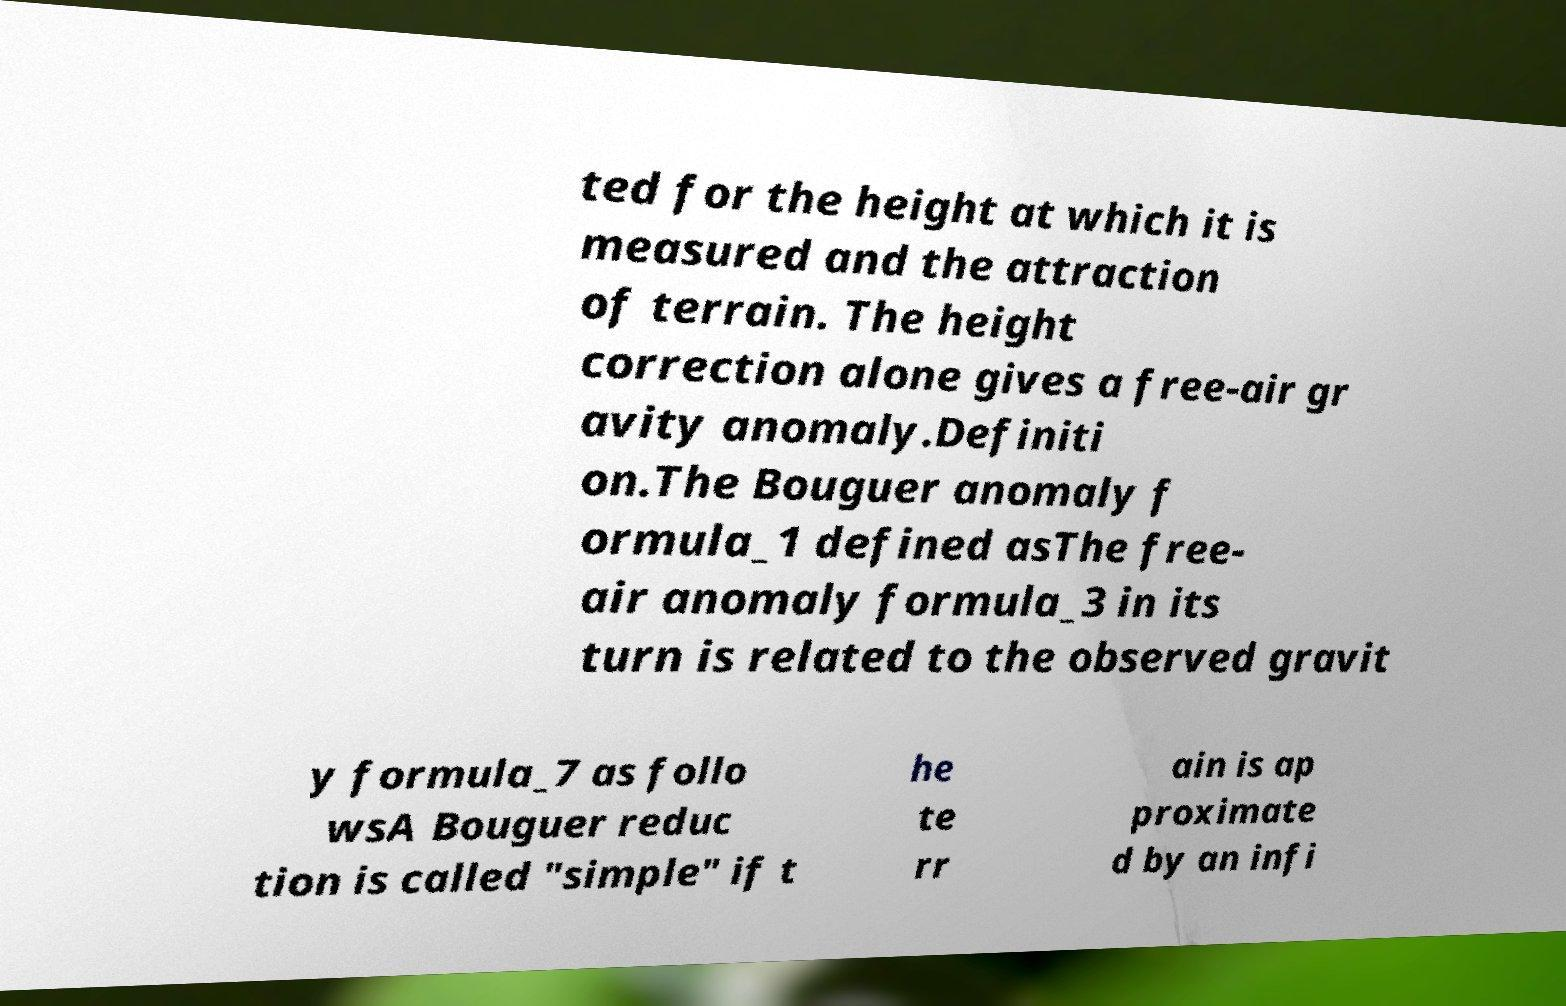Please read and relay the text visible in this image. What does it say? ted for the height at which it is measured and the attraction of terrain. The height correction alone gives a free-air gr avity anomaly.Definiti on.The Bouguer anomaly f ormula_1 defined asThe free- air anomaly formula_3 in its turn is related to the observed gravit y formula_7 as follo wsA Bouguer reduc tion is called "simple" if t he te rr ain is ap proximate d by an infi 